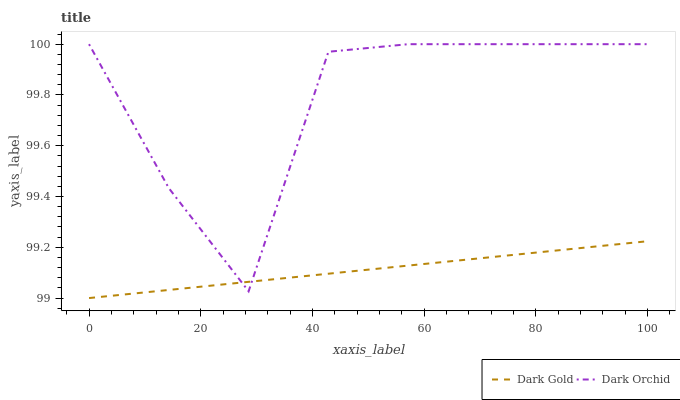Does Dark Gold have the minimum area under the curve?
Answer yes or no. Yes. Does Dark Orchid have the maximum area under the curve?
Answer yes or no. Yes. Does Dark Gold have the maximum area under the curve?
Answer yes or no. No. Is Dark Gold the smoothest?
Answer yes or no. Yes. Is Dark Orchid the roughest?
Answer yes or no. Yes. Is Dark Gold the roughest?
Answer yes or no. No. Does Dark Orchid have the highest value?
Answer yes or no. Yes. Does Dark Gold have the highest value?
Answer yes or no. No. Does Dark Orchid intersect Dark Gold?
Answer yes or no. Yes. Is Dark Orchid less than Dark Gold?
Answer yes or no. No. Is Dark Orchid greater than Dark Gold?
Answer yes or no. No. 